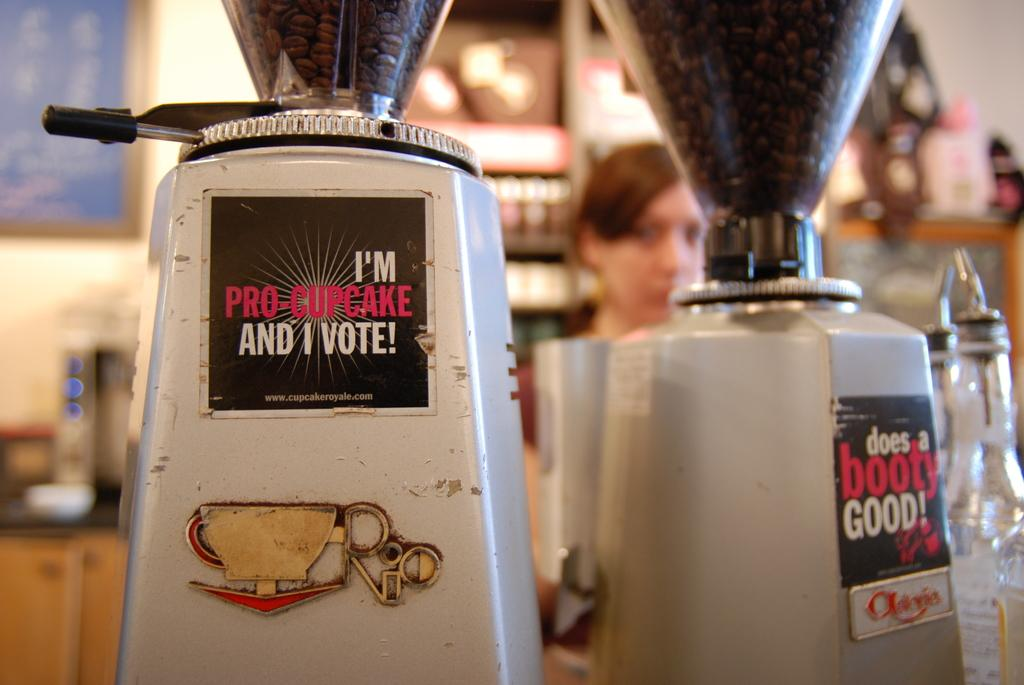What can be seen in the image related to machinery? There are machines in the image. What type of raw material is present in the image? There are coffee beans in the image. What type of containers are visible in the image? There are bottles in the image. Can you describe the person in the image? There is a person in the image. What can be seen in the background of the image? The background of the image contains some objects. How would you describe the clarity of the background in the image? The background of the image is blurry. What type of test is being conducted on the table in the image? There is no table present in the image, and no test is being conducted. What type of process is being carried out on the coffee beans in the image? The image does not show any process being carried out on the coffee beans; they are simply present in the image. 